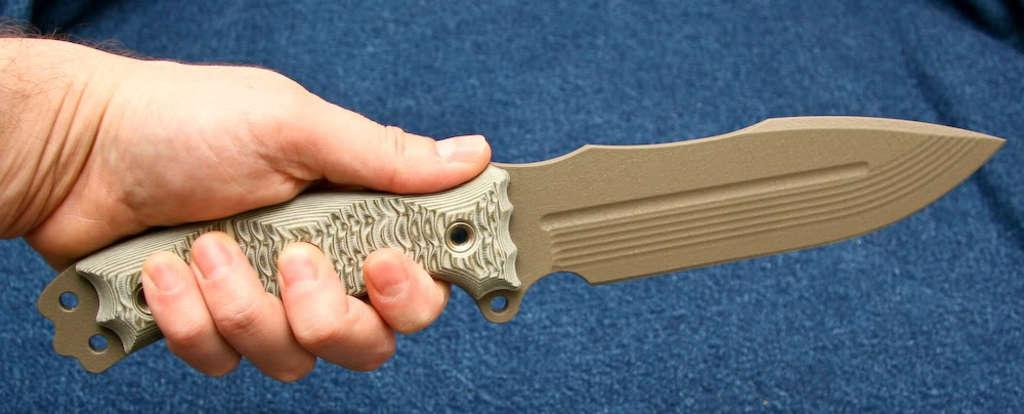What is present in the image? There is a person in the image. What is the person holding in the image? The person is holding a knife. How much money is on the desk in the image? There is no desk or money present in the image; only a person holding a knife is visible. 